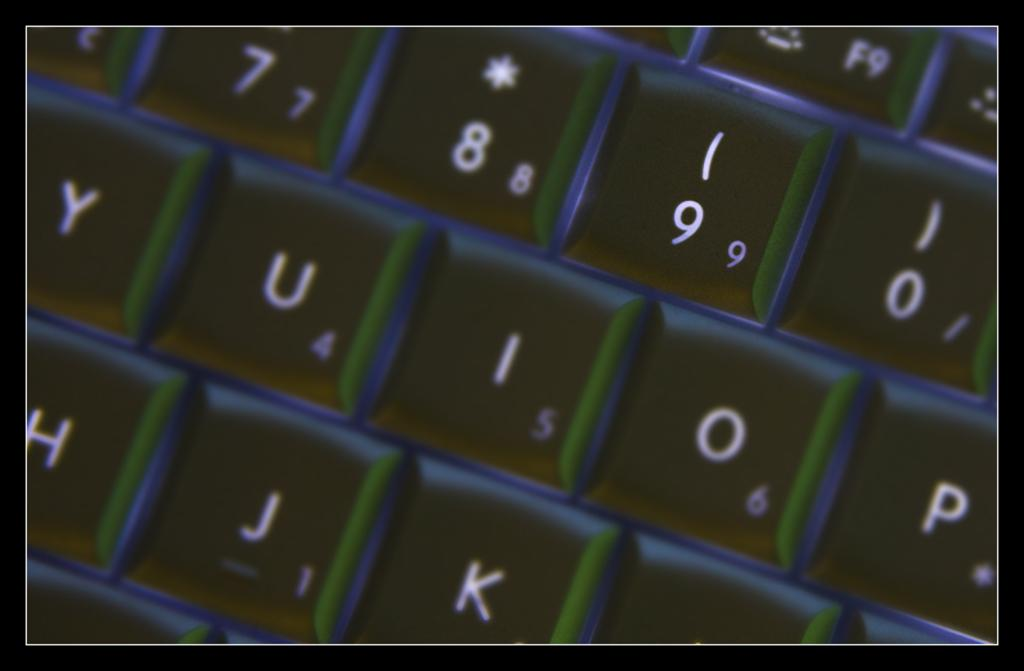<image>
Present a compact description of the photo's key features. A close up of a keyboard - the letter I is near the middle 